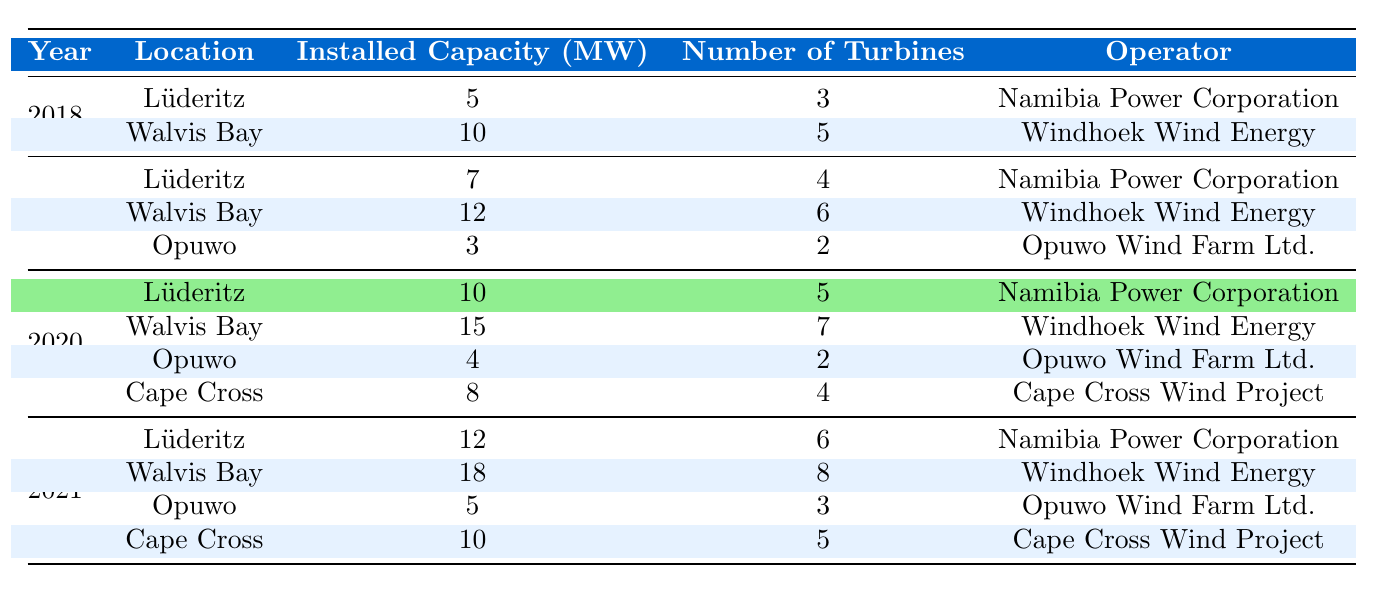What is the installed capacity of wind energy in Lüderitz for the year 2020? From the table, for the year 2020, the installed capacity of wind energy in Lüderitz is listed as 10 MW.
Answer: 10 MW Which operator managed the wind energy project with the highest installed capacity in 2021? In the table for 2021, Walvis Bay shows an installed capacity of 18 MW, which is the highest among all locations, and its operator is Windhoek Wind Energy.
Answer: Windhoek Wind Energy What is the total installed capacity of wind energy from all locations in Namibia in 2019? To get the total, we sum the installed capacities for each location in 2019: 7 (Lüderitz) + 12 (Walvis Bay) + 3 (Opuwo) = 22 MW.
Answer: 22 MW Did Opuwo's installed capacity increase from 2019 to 2021? In 2019, Opuwo had an installed capacity of 3 MW, which increased to 5 MW in 2021. Therefore, the capacity increased over the years.
Answer: Yes What is the average number of turbines for projects in Walvis Bay from 2018 to 2021? The number of turbines for Walvis Bay over the years is as follows: 5 (2018) + 6 (2019) + 7 (2020) + 8 (2021) = 26. There are 4 data points, so the average is: 26/4 = 6.5.
Answer: 6.5 How many total wind turbines were installed in Cape Cross as of 2021? According to the table, Cape Cross had 4 turbines in 2020 and increased to 5 turbines in 2021. Summing these gives a total of 9 turbines installed by 2021.
Answer: 9 Was the installed capacity in Lüderitz higher in 2021 compared to 2018? In Lüderitz, the installed capacity was 5 MW in 2018 and increased to 12 MW in 2021. Thus, it was indeed higher in 2021.
Answer: Yes What was the increase in installed capacity in Walvis Bay from 2020 to 2021? The installed capacity in Walvis Bay was 15 MW in 2020 and increased to 18 MW in 2021. The increase is calculated as: 18 - 15 = 3 MW.
Answer: 3 MW 